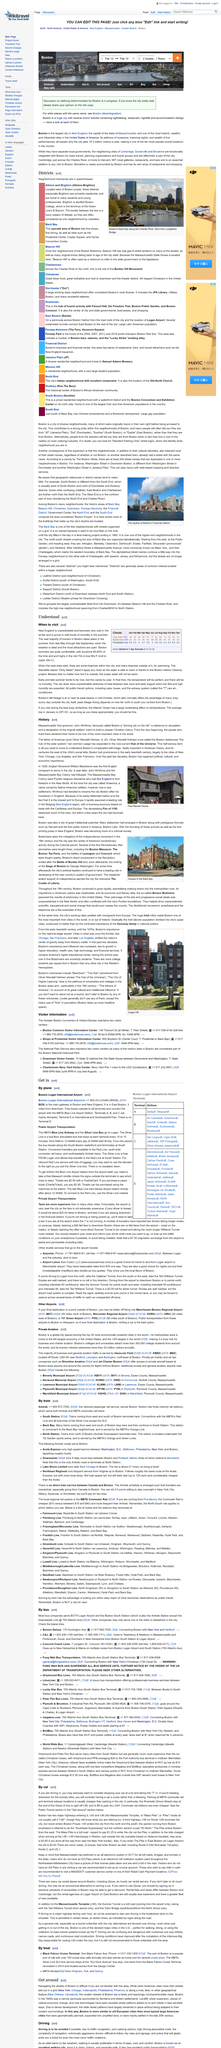Outline some significant characteristics in this image. The weather in Boston during the summer is typically warm, with temperatures ranging from the high 70s to low 80s Fahrenheit. The Charles River is a river that flows alongside Back Bay. The image depicts Boston's Back Bay, and the area is clearly visible. Boston experiences the bulk of its tourism in the summer season. The weather in New England is unpredictable and can become cold in the winter, with occasional bouts of humidity in the summer. 